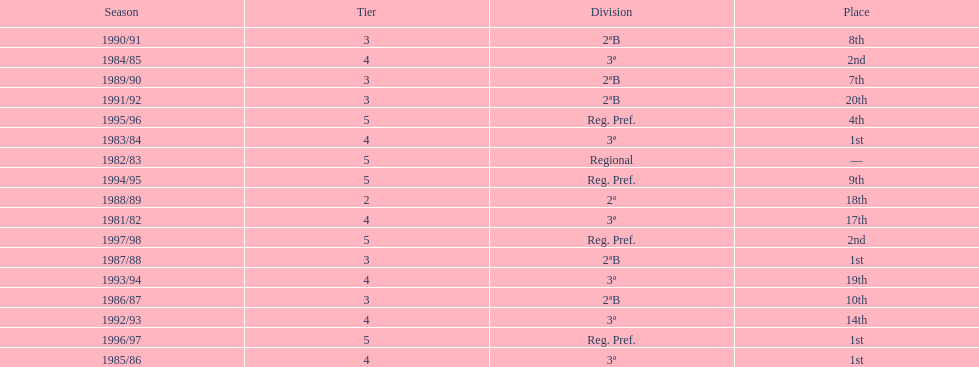How many seasons are shown in this chart? 17. 